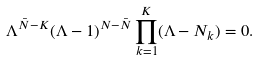Convert formula to latex. <formula><loc_0><loc_0><loc_500><loc_500>\Lambda ^ { \bar { N } - K } ( \Lambda - 1 ) ^ { N - \bar { N } } \prod _ { k = 1 } ^ { K } ( \Lambda - N _ { k } ) = 0 .</formula> 